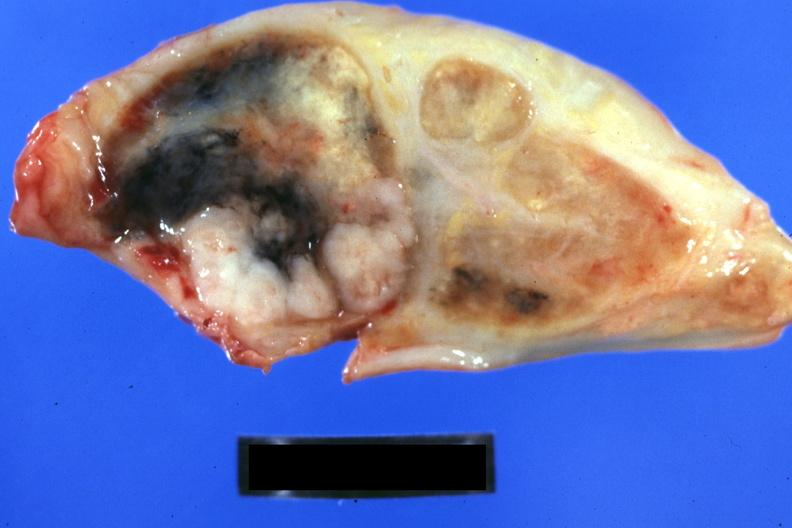what is present?
Answer the question using a single word or phrase. Metastatic carcinoma lung 